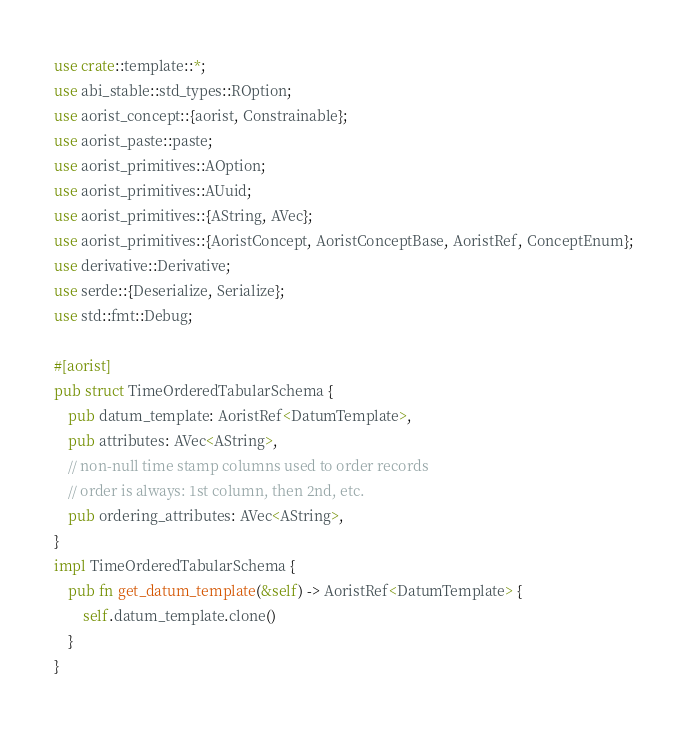<code> <loc_0><loc_0><loc_500><loc_500><_Rust_>use crate::template::*;
use abi_stable::std_types::ROption;
use aorist_concept::{aorist, Constrainable};
use aorist_paste::paste;
use aorist_primitives::AOption;
use aorist_primitives::AUuid;
use aorist_primitives::{AString, AVec};
use aorist_primitives::{AoristConcept, AoristConceptBase, AoristRef, ConceptEnum};
use derivative::Derivative;
use serde::{Deserialize, Serialize};
use std::fmt::Debug;

#[aorist]
pub struct TimeOrderedTabularSchema {
    pub datum_template: AoristRef<DatumTemplate>,
    pub attributes: AVec<AString>,
    // non-null time stamp columns used to order records
    // order is always: 1st column, then 2nd, etc.
    pub ordering_attributes: AVec<AString>,
}
impl TimeOrderedTabularSchema {
    pub fn get_datum_template(&self) -> AoristRef<DatumTemplate> {
        self.datum_template.clone()
    }
}
</code> 